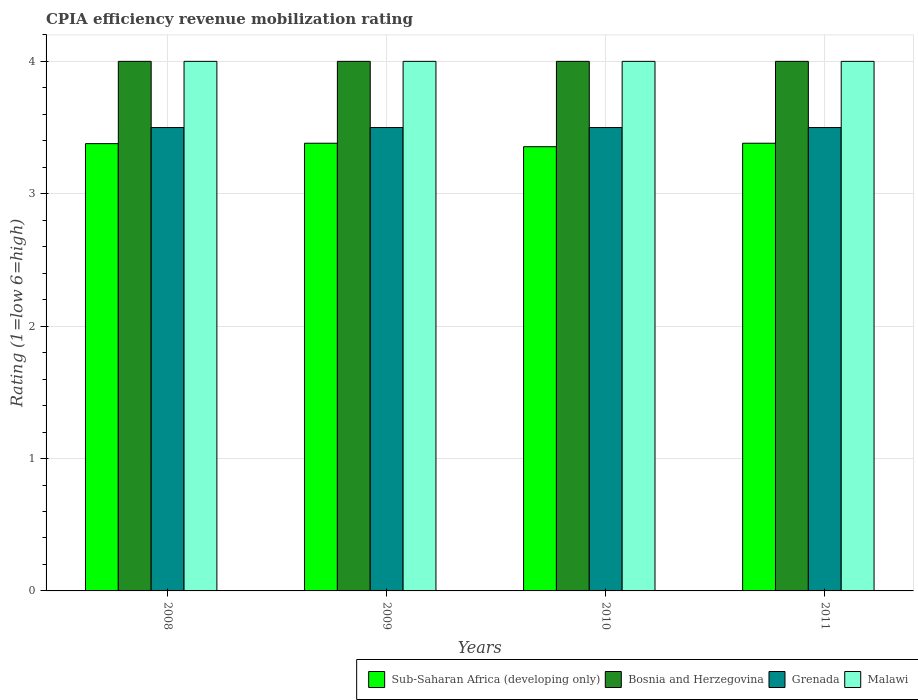How many different coloured bars are there?
Your response must be concise. 4. Are the number of bars per tick equal to the number of legend labels?
Ensure brevity in your answer.  Yes. What is the CPIA rating in Malawi in 2008?
Offer a terse response. 4. Across all years, what is the maximum CPIA rating in Bosnia and Herzegovina?
Offer a very short reply. 4. Across all years, what is the minimum CPIA rating in Grenada?
Ensure brevity in your answer.  3.5. In which year was the CPIA rating in Malawi minimum?
Give a very brief answer. 2008. What is the total CPIA rating in Sub-Saharan Africa (developing only) in the graph?
Provide a short and direct response. 13.5. What is the difference between the CPIA rating in Grenada in 2009 and that in 2011?
Give a very brief answer. 0. What is the difference between the CPIA rating in Malawi in 2008 and the CPIA rating in Bosnia and Herzegovina in 2009?
Give a very brief answer. 0. What is the average CPIA rating in Grenada per year?
Your response must be concise. 3.5. In the year 2008, what is the difference between the CPIA rating in Malawi and CPIA rating in Sub-Saharan Africa (developing only)?
Offer a very short reply. 0.62. In how many years, is the CPIA rating in Grenada greater than 1.2?
Offer a very short reply. 4. What is the ratio of the CPIA rating in Grenada in 2009 to that in 2011?
Your response must be concise. 1. Is the CPIA rating in Sub-Saharan Africa (developing only) in 2009 less than that in 2011?
Provide a short and direct response. No. What is the difference between the highest and the second highest CPIA rating in Grenada?
Your answer should be compact. 0. In how many years, is the CPIA rating in Sub-Saharan Africa (developing only) greater than the average CPIA rating in Sub-Saharan Africa (developing only) taken over all years?
Provide a short and direct response. 3. What does the 4th bar from the left in 2008 represents?
Offer a terse response. Malawi. What does the 2nd bar from the right in 2009 represents?
Offer a very short reply. Grenada. Are all the bars in the graph horizontal?
Ensure brevity in your answer.  No. How many years are there in the graph?
Provide a short and direct response. 4. What is the difference between two consecutive major ticks on the Y-axis?
Provide a succinct answer. 1. Does the graph contain any zero values?
Provide a short and direct response. No. Where does the legend appear in the graph?
Offer a very short reply. Bottom right. How many legend labels are there?
Ensure brevity in your answer.  4. How are the legend labels stacked?
Provide a succinct answer. Horizontal. What is the title of the graph?
Provide a succinct answer. CPIA efficiency revenue mobilization rating. Does "Ghana" appear as one of the legend labels in the graph?
Your answer should be compact. No. What is the label or title of the X-axis?
Provide a succinct answer. Years. What is the label or title of the Y-axis?
Provide a short and direct response. Rating (1=low 6=high). What is the Rating (1=low 6=high) in Sub-Saharan Africa (developing only) in 2008?
Give a very brief answer. 3.38. What is the Rating (1=low 6=high) of Bosnia and Herzegovina in 2008?
Give a very brief answer. 4. What is the Rating (1=low 6=high) of Grenada in 2008?
Offer a very short reply. 3.5. What is the Rating (1=low 6=high) in Sub-Saharan Africa (developing only) in 2009?
Ensure brevity in your answer.  3.38. What is the Rating (1=low 6=high) in Bosnia and Herzegovina in 2009?
Give a very brief answer. 4. What is the Rating (1=low 6=high) of Grenada in 2009?
Keep it short and to the point. 3.5. What is the Rating (1=low 6=high) in Sub-Saharan Africa (developing only) in 2010?
Offer a terse response. 3.36. What is the Rating (1=low 6=high) in Bosnia and Herzegovina in 2010?
Provide a short and direct response. 4. What is the Rating (1=low 6=high) of Grenada in 2010?
Offer a very short reply. 3.5. What is the Rating (1=low 6=high) in Malawi in 2010?
Make the answer very short. 4. What is the Rating (1=low 6=high) in Sub-Saharan Africa (developing only) in 2011?
Offer a very short reply. 3.38. What is the Rating (1=low 6=high) in Grenada in 2011?
Make the answer very short. 3.5. What is the Rating (1=low 6=high) in Malawi in 2011?
Your response must be concise. 4. Across all years, what is the maximum Rating (1=low 6=high) in Sub-Saharan Africa (developing only)?
Offer a very short reply. 3.38. Across all years, what is the maximum Rating (1=low 6=high) of Grenada?
Offer a terse response. 3.5. Across all years, what is the maximum Rating (1=low 6=high) of Malawi?
Your response must be concise. 4. Across all years, what is the minimum Rating (1=low 6=high) of Sub-Saharan Africa (developing only)?
Provide a succinct answer. 3.36. What is the total Rating (1=low 6=high) of Sub-Saharan Africa (developing only) in the graph?
Offer a terse response. 13.5. What is the total Rating (1=low 6=high) in Malawi in the graph?
Your response must be concise. 16. What is the difference between the Rating (1=low 6=high) of Sub-Saharan Africa (developing only) in 2008 and that in 2009?
Your response must be concise. -0. What is the difference between the Rating (1=low 6=high) in Bosnia and Herzegovina in 2008 and that in 2009?
Keep it short and to the point. 0. What is the difference between the Rating (1=low 6=high) of Malawi in 2008 and that in 2009?
Your answer should be compact. 0. What is the difference between the Rating (1=low 6=high) in Sub-Saharan Africa (developing only) in 2008 and that in 2010?
Your answer should be compact. 0.02. What is the difference between the Rating (1=low 6=high) in Grenada in 2008 and that in 2010?
Keep it short and to the point. 0. What is the difference between the Rating (1=low 6=high) of Sub-Saharan Africa (developing only) in 2008 and that in 2011?
Provide a short and direct response. -0. What is the difference between the Rating (1=low 6=high) in Malawi in 2008 and that in 2011?
Keep it short and to the point. 0. What is the difference between the Rating (1=low 6=high) of Sub-Saharan Africa (developing only) in 2009 and that in 2010?
Your response must be concise. 0.03. What is the difference between the Rating (1=low 6=high) of Bosnia and Herzegovina in 2009 and that in 2010?
Offer a very short reply. 0. What is the difference between the Rating (1=low 6=high) of Malawi in 2009 and that in 2010?
Your response must be concise. 0. What is the difference between the Rating (1=low 6=high) in Grenada in 2009 and that in 2011?
Ensure brevity in your answer.  0. What is the difference between the Rating (1=low 6=high) of Sub-Saharan Africa (developing only) in 2010 and that in 2011?
Your response must be concise. -0.03. What is the difference between the Rating (1=low 6=high) of Bosnia and Herzegovina in 2010 and that in 2011?
Provide a short and direct response. 0. What is the difference between the Rating (1=low 6=high) in Grenada in 2010 and that in 2011?
Offer a terse response. 0. What is the difference between the Rating (1=low 6=high) in Malawi in 2010 and that in 2011?
Your answer should be compact. 0. What is the difference between the Rating (1=low 6=high) in Sub-Saharan Africa (developing only) in 2008 and the Rating (1=low 6=high) in Bosnia and Herzegovina in 2009?
Provide a short and direct response. -0.62. What is the difference between the Rating (1=low 6=high) in Sub-Saharan Africa (developing only) in 2008 and the Rating (1=low 6=high) in Grenada in 2009?
Provide a short and direct response. -0.12. What is the difference between the Rating (1=low 6=high) in Sub-Saharan Africa (developing only) in 2008 and the Rating (1=low 6=high) in Malawi in 2009?
Make the answer very short. -0.62. What is the difference between the Rating (1=low 6=high) of Bosnia and Herzegovina in 2008 and the Rating (1=low 6=high) of Grenada in 2009?
Provide a short and direct response. 0.5. What is the difference between the Rating (1=low 6=high) of Grenada in 2008 and the Rating (1=low 6=high) of Malawi in 2009?
Provide a short and direct response. -0.5. What is the difference between the Rating (1=low 6=high) in Sub-Saharan Africa (developing only) in 2008 and the Rating (1=low 6=high) in Bosnia and Herzegovina in 2010?
Make the answer very short. -0.62. What is the difference between the Rating (1=low 6=high) of Sub-Saharan Africa (developing only) in 2008 and the Rating (1=low 6=high) of Grenada in 2010?
Provide a short and direct response. -0.12. What is the difference between the Rating (1=low 6=high) of Sub-Saharan Africa (developing only) in 2008 and the Rating (1=low 6=high) of Malawi in 2010?
Ensure brevity in your answer.  -0.62. What is the difference between the Rating (1=low 6=high) in Bosnia and Herzegovina in 2008 and the Rating (1=low 6=high) in Malawi in 2010?
Keep it short and to the point. 0. What is the difference between the Rating (1=low 6=high) in Grenada in 2008 and the Rating (1=low 6=high) in Malawi in 2010?
Your response must be concise. -0.5. What is the difference between the Rating (1=low 6=high) of Sub-Saharan Africa (developing only) in 2008 and the Rating (1=low 6=high) of Bosnia and Herzegovina in 2011?
Keep it short and to the point. -0.62. What is the difference between the Rating (1=low 6=high) of Sub-Saharan Africa (developing only) in 2008 and the Rating (1=low 6=high) of Grenada in 2011?
Give a very brief answer. -0.12. What is the difference between the Rating (1=low 6=high) of Sub-Saharan Africa (developing only) in 2008 and the Rating (1=low 6=high) of Malawi in 2011?
Offer a terse response. -0.62. What is the difference between the Rating (1=low 6=high) in Bosnia and Herzegovina in 2008 and the Rating (1=low 6=high) in Malawi in 2011?
Make the answer very short. 0. What is the difference between the Rating (1=low 6=high) in Sub-Saharan Africa (developing only) in 2009 and the Rating (1=low 6=high) in Bosnia and Herzegovina in 2010?
Your answer should be compact. -0.62. What is the difference between the Rating (1=low 6=high) in Sub-Saharan Africa (developing only) in 2009 and the Rating (1=low 6=high) in Grenada in 2010?
Ensure brevity in your answer.  -0.12. What is the difference between the Rating (1=low 6=high) of Sub-Saharan Africa (developing only) in 2009 and the Rating (1=low 6=high) of Malawi in 2010?
Ensure brevity in your answer.  -0.62. What is the difference between the Rating (1=low 6=high) in Bosnia and Herzegovina in 2009 and the Rating (1=low 6=high) in Grenada in 2010?
Offer a terse response. 0.5. What is the difference between the Rating (1=low 6=high) of Bosnia and Herzegovina in 2009 and the Rating (1=low 6=high) of Malawi in 2010?
Your answer should be compact. 0. What is the difference between the Rating (1=low 6=high) in Grenada in 2009 and the Rating (1=low 6=high) in Malawi in 2010?
Your answer should be compact. -0.5. What is the difference between the Rating (1=low 6=high) in Sub-Saharan Africa (developing only) in 2009 and the Rating (1=low 6=high) in Bosnia and Herzegovina in 2011?
Give a very brief answer. -0.62. What is the difference between the Rating (1=low 6=high) in Sub-Saharan Africa (developing only) in 2009 and the Rating (1=low 6=high) in Grenada in 2011?
Your answer should be compact. -0.12. What is the difference between the Rating (1=low 6=high) of Sub-Saharan Africa (developing only) in 2009 and the Rating (1=low 6=high) of Malawi in 2011?
Provide a succinct answer. -0.62. What is the difference between the Rating (1=low 6=high) of Sub-Saharan Africa (developing only) in 2010 and the Rating (1=low 6=high) of Bosnia and Herzegovina in 2011?
Offer a terse response. -0.64. What is the difference between the Rating (1=low 6=high) of Sub-Saharan Africa (developing only) in 2010 and the Rating (1=low 6=high) of Grenada in 2011?
Give a very brief answer. -0.14. What is the difference between the Rating (1=low 6=high) in Sub-Saharan Africa (developing only) in 2010 and the Rating (1=low 6=high) in Malawi in 2011?
Offer a very short reply. -0.64. What is the difference between the Rating (1=low 6=high) of Bosnia and Herzegovina in 2010 and the Rating (1=low 6=high) of Grenada in 2011?
Provide a short and direct response. 0.5. What is the difference between the Rating (1=low 6=high) of Bosnia and Herzegovina in 2010 and the Rating (1=low 6=high) of Malawi in 2011?
Your response must be concise. 0. What is the average Rating (1=low 6=high) in Sub-Saharan Africa (developing only) per year?
Your response must be concise. 3.37. What is the average Rating (1=low 6=high) in Malawi per year?
Your response must be concise. 4. In the year 2008, what is the difference between the Rating (1=low 6=high) of Sub-Saharan Africa (developing only) and Rating (1=low 6=high) of Bosnia and Herzegovina?
Your answer should be compact. -0.62. In the year 2008, what is the difference between the Rating (1=low 6=high) of Sub-Saharan Africa (developing only) and Rating (1=low 6=high) of Grenada?
Provide a short and direct response. -0.12. In the year 2008, what is the difference between the Rating (1=low 6=high) of Sub-Saharan Africa (developing only) and Rating (1=low 6=high) of Malawi?
Your response must be concise. -0.62. In the year 2008, what is the difference between the Rating (1=low 6=high) of Grenada and Rating (1=low 6=high) of Malawi?
Give a very brief answer. -0.5. In the year 2009, what is the difference between the Rating (1=low 6=high) of Sub-Saharan Africa (developing only) and Rating (1=low 6=high) of Bosnia and Herzegovina?
Your answer should be very brief. -0.62. In the year 2009, what is the difference between the Rating (1=low 6=high) in Sub-Saharan Africa (developing only) and Rating (1=low 6=high) in Grenada?
Provide a short and direct response. -0.12. In the year 2009, what is the difference between the Rating (1=low 6=high) of Sub-Saharan Africa (developing only) and Rating (1=low 6=high) of Malawi?
Give a very brief answer. -0.62. In the year 2009, what is the difference between the Rating (1=low 6=high) in Bosnia and Herzegovina and Rating (1=low 6=high) in Grenada?
Provide a succinct answer. 0.5. In the year 2009, what is the difference between the Rating (1=low 6=high) of Bosnia and Herzegovina and Rating (1=low 6=high) of Malawi?
Provide a short and direct response. 0. In the year 2009, what is the difference between the Rating (1=low 6=high) of Grenada and Rating (1=low 6=high) of Malawi?
Provide a short and direct response. -0.5. In the year 2010, what is the difference between the Rating (1=low 6=high) in Sub-Saharan Africa (developing only) and Rating (1=low 6=high) in Bosnia and Herzegovina?
Your response must be concise. -0.64. In the year 2010, what is the difference between the Rating (1=low 6=high) of Sub-Saharan Africa (developing only) and Rating (1=low 6=high) of Grenada?
Your response must be concise. -0.14. In the year 2010, what is the difference between the Rating (1=low 6=high) in Sub-Saharan Africa (developing only) and Rating (1=low 6=high) in Malawi?
Your answer should be very brief. -0.64. In the year 2010, what is the difference between the Rating (1=low 6=high) in Bosnia and Herzegovina and Rating (1=low 6=high) in Malawi?
Your response must be concise. 0. In the year 2010, what is the difference between the Rating (1=low 6=high) of Grenada and Rating (1=low 6=high) of Malawi?
Your response must be concise. -0.5. In the year 2011, what is the difference between the Rating (1=low 6=high) of Sub-Saharan Africa (developing only) and Rating (1=low 6=high) of Bosnia and Herzegovina?
Ensure brevity in your answer.  -0.62. In the year 2011, what is the difference between the Rating (1=low 6=high) of Sub-Saharan Africa (developing only) and Rating (1=low 6=high) of Grenada?
Offer a terse response. -0.12. In the year 2011, what is the difference between the Rating (1=low 6=high) of Sub-Saharan Africa (developing only) and Rating (1=low 6=high) of Malawi?
Offer a terse response. -0.62. In the year 2011, what is the difference between the Rating (1=low 6=high) in Bosnia and Herzegovina and Rating (1=low 6=high) in Malawi?
Offer a terse response. 0. What is the ratio of the Rating (1=low 6=high) of Sub-Saharan Africa (developing only) in 2008 to that in 2009?
Keep it short and to the point. 1. What is the ratio of the Rating (1=low 6=high) in Grenada in 2008 to that in 2009?
Provide a short and direct response. 1. What is the ratio of the Rating (1=low 6=high) of Bosnia and Herzegovina in 2008 to that in 2011?
Provide a succinct answer. 1. What is the ratio of the Rating (1=low 6=high) of Grenada in 2008 to that in 2011?
Offer a very short reply. 1. What is the ratio of the Rating (1=low 6=high) of Malawi in 2008 to that in 2011?
Ensure brevity in your answer.  1. What is the ratio of the Rating (1=low 6=high) in Sub-Saharan Africa (developing only) in 2009 to that in 2010?
Ensure brevity in your answer.  1.01. What is the ratio of the Rating (1=low 6=high) in Malawi in 2009 to that in 2010?
Offer a very short reply. 1. What is the ratio of the Rating (1=low 6=high) in Sub-Saharan Africa (developing only) in 2009 to that in 2011?
Your response must be concise. 1. What is the ratio of the Rating (1=low 6=high) in Grenada in 2009 to that in 2011?
Make the answer very short. 1. What is the ratio of the Rating (1=low 6=high) of Grenada in 2010 to that in 2011?
Offer a very short reply. 1. What is the ratio of the Rating (1=low 6=high) of Malawi in 2010 to that in 2011?
Your answer should be very brief. 1. What is the difference between the highest and the second highest Rating (1=low 6=high) in Sub-Saharan Africa (developing only)?
Your answer should be very brief. 0. What is the difference between the highest and the second highest Rating (1=low 6=high) in Malawi?
Offer a terse response. 0. What is the difference between the highest and the lowest Rating (1=low 6=high) of Sub-Saharan Africa (developing only)?
Offer a very short reply. 0.03. What is the difference between the highest and the lowest Rating (1=low 6=high) in Bosnia and Herzegovina?
Provide a succinct answer. 0. 